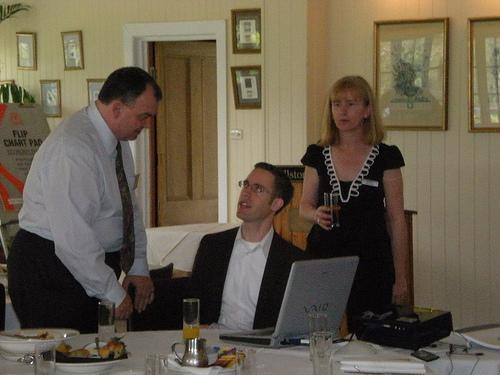Where is this venue likely to be?

Choices:
A) home
B) conference room
C) office
D) restaurant conference room 